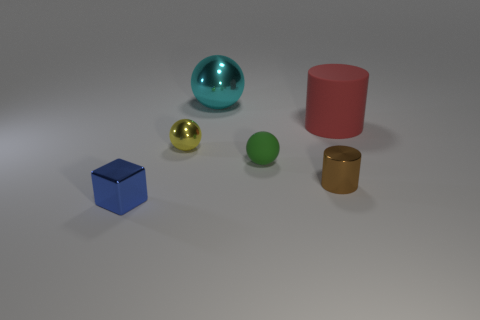There is a tiny brown cylinder; what number of rubber objects are to the right of it? 1 